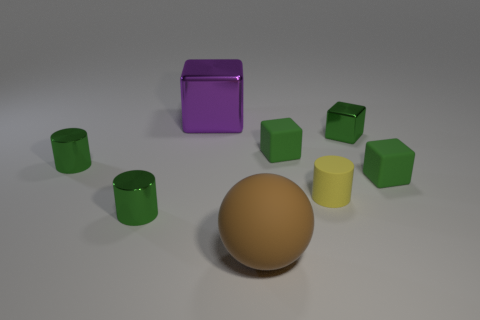Is the large purple cube made of the same material as the cylinder to the right of the big purple metal thing?
Offer a terse response. No. The metallic thing behind the metallic cube on the right side of the metal cube that is to the left of the brown rubber ball is what color?
Keep it short and to the point. Purple. What shape is the brown rubber object that is the same size as the purple object?
Your response must be concise. Sphere. Is there anything else that is the same size as the brown matte object?
Keep it short and to the point. Yes. Do the shiny object to the right of the large brown matte sphere and the cylinder that is to the right of the brown thing have the same size?
Your answer should be compact. Yes. What is the size of the green shiny thing that is to the right of the big matte thing?
Your answer should be very brief. Small. There is a metal thing that is the same size as the brown rubber ball; what is its color?
Offer a very short reply. Purple. Is the yellow object the same size as the green metal cube?
Make the answer very short. Yes. There is a thing that is both in front of the yellow matte cylinder and to the left of the large matte object; what is its size?
Keep it short and to the point. Small. How many rubber things are either green blocks or brown cylinders?
Make the answer very short. 2. 